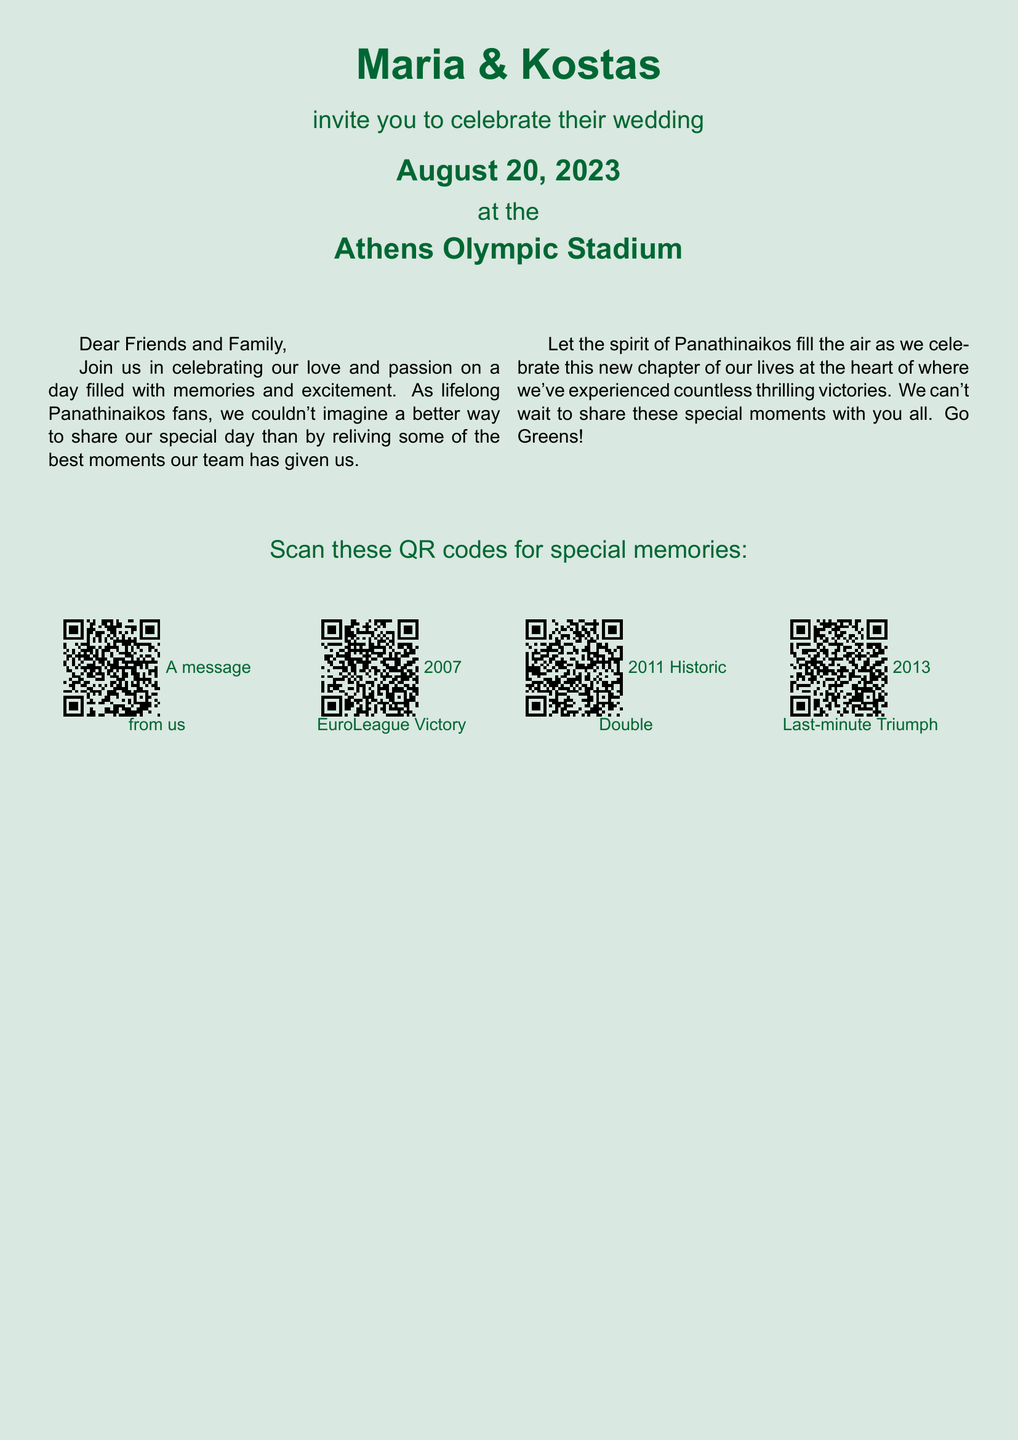What are the names of the couple? The names of the couple are prominently displayed at the top of the invitation.
Answer: Maria & Kostas What is the wedding date? The wedding date is explicitly mentioned in the invitation text.
Answer: August 20, 2023 Where is the wedding taking place? The location of the wedding is clearly stated in the document.
Answer: Athens Olympic Stadium What color is the background of the invitation? The color of the background is described through the document's formatting.
Answer: Panathinaikos Green What message is associated with the first QR code? The first QR code directs to a specific message from the couple mentioned in the text.
Answer: A message from us Which Panathinaikos victory is highlighted with a QR code in 2007? The invitation specifies a notable victory linked to the QR codes provided.
Answer: EuroLeague Victory Which major rivalry event does the 2011 QR code refer to? The 2011 QR code is linked to a significant historical moment in Panathinaikos' history.
Answer: Historic Double How many QR codes are included in the wedding invitation? The invitation lists a certain number of QR codes for special memories.
Answer: Four What is the overall theme of the invitation? The overarching theme of the invitation is emphasized throughout the text.
Answer: Panathinaikos passion 